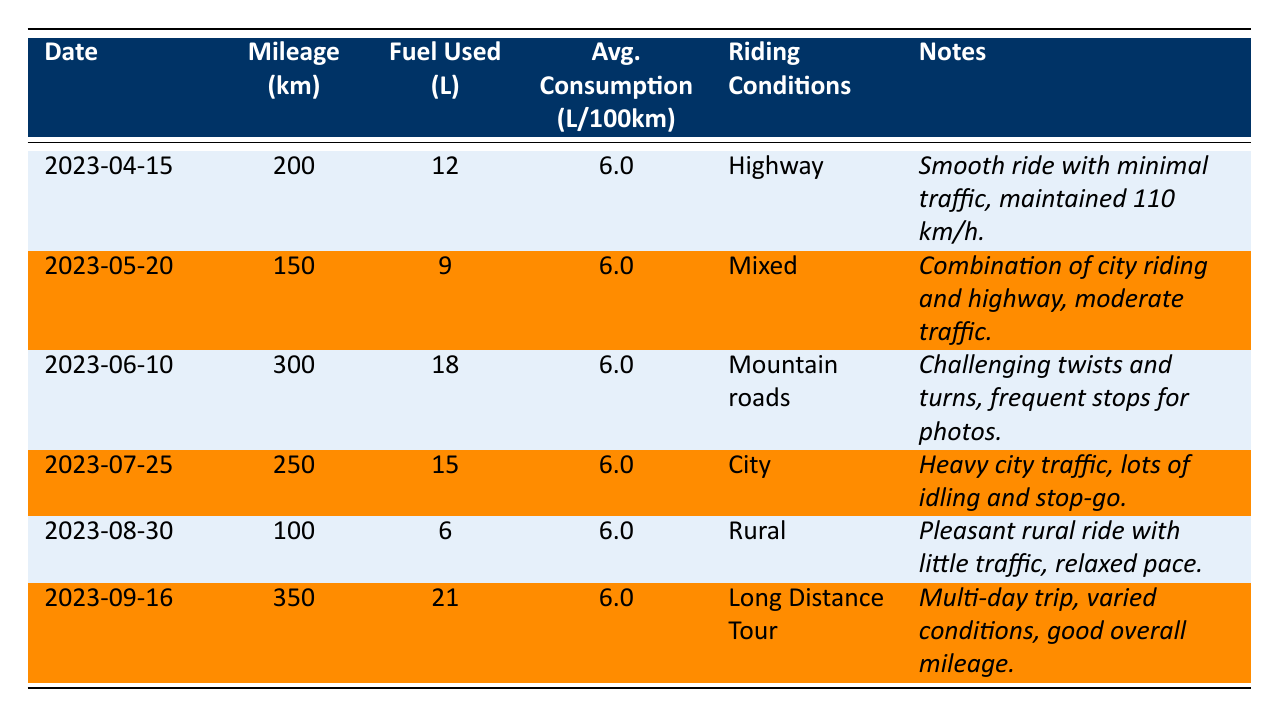What was the fuel consumption on April 15, 2023? On April 15, 2023, the table indicates that 12 liters of fuel were consumed.
Answer: 12 liters What was the total mileage recorded from all entries? Adding up the mileage from each entry: 200 + 150 + 300 + 250 + 100 + 350 = 1350 km.
Answer: 1350 km Was the fuel consumption consistent across all rides? Yes, the average consumption was consistently 6.0 liters per 100 km for all entries.
Answer: Yes How much fuel was consumed during the Long Distance Tour on September 16, 2023? The table shows that 21 liters of fuel were consumed during this ride.
Answer: 21 liters Which riding condition had the highest mileage, and what was that mileage? The riding condition with the highest mileage was Long Distance Tour with 350 km.
Answer: 350 km What was the average fuel consumption for city riding based on the table? The city riding entry on July 25 shows fuel consumption of 15 liters for 250 km, which calculates to (15/250)*100 = 6.0 liters per 100 km, consistent with others.
Answer: 6.0 liters per 100 km Was there any ride where fuel consumption exceeded 20 liters? Yes, the ride on September 16, 2023, exceeded 20 liters with a consumption of 21 liters.
Answer: Yes What was the difference in mileage between the ride on June 10 and the ride on August 30? The mileage on June 10 is 300 km and on August 30 is 100 km, so the difference is 300 - 100 = 200 km.
Answer: 200 km How many liters of fuel were consumed during rides with mixed conditions? The ride with mixed conditions on May 20 consumed 9 liters, and there were no other mixed condition entries. Total is 9 liters.
Answer: 9 liters Did any entry indicate heavy traffic conditions? Yes, the entry on July 25 describes heavy city traffic.
Answer: Yes What was the total amount of fuel consumed for rides classified as 'highway'? The only highway entry on April 15 consumed 12 liters, so the total is 12 liters.
Answer: 12 liters 